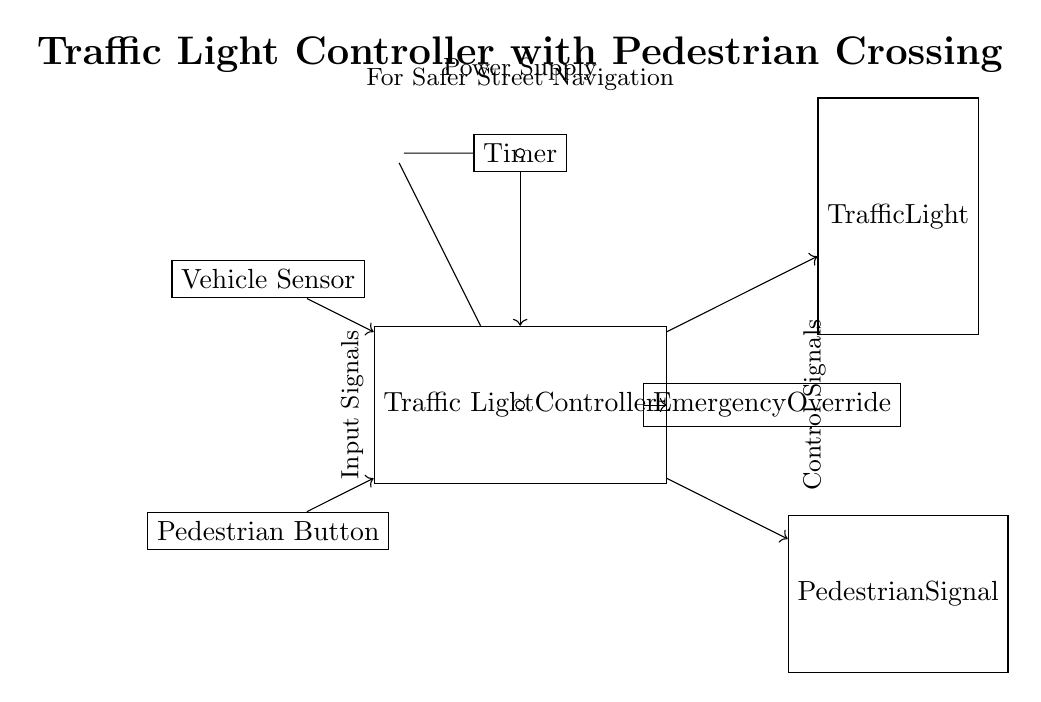What is the main component of this circuit? The main component is the Traffic Light Controller, which is represented as the largest rectangle in the diagram. This controller connects all inputs and outputs of the circuit.
Answer: Traffic Light Controller How many sensors are included in this circuit? The diagram shows two sensors: a Vehicle Sensor and a Pedestrian Button. Counting these components gives a total of two sensors.
Answer: 2 What does the timer component do in this circuit? The timer is responsible for regulating the timing of the traffic light and pedestrian signals, providing a control signal to the Traffic Light Controller based on its settings.
Answer: Regulates timing What is the function of the emergency override? The Emergency Override allows for manual control of the traffic light in critical situations, providing an alternative input to the Traffic Light Controller to ensure safety.
Answer: Manual control Where is the power supply located? The power supply is represented by a battery, which is located at the top left of the diagram. It supplies power to both the Timer and the Traffic Light Controller.
Answer: Top left What type of signals do the sensors provide to the controller? The sensors provide input signals, which are necessary for the Traffic Light Controller to make decisions about traffic light changes and pedestrian crossings.
Answer: Input signals 